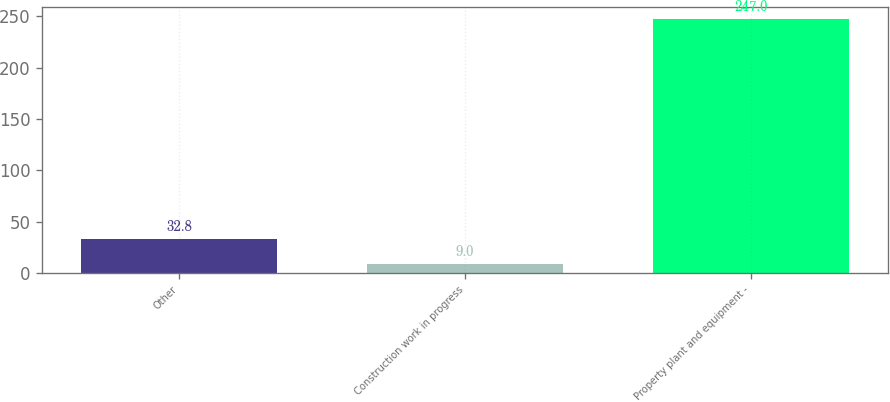Convert chart. <chart><loc_0><loc_0><loc_500><loc_500><bar_chart><fcel>Other<fcel>Construction work in progress<fcel>Property plant and equipment -<nl><fcel>32.8<fcel>9<fcel>247<nl></chart> 